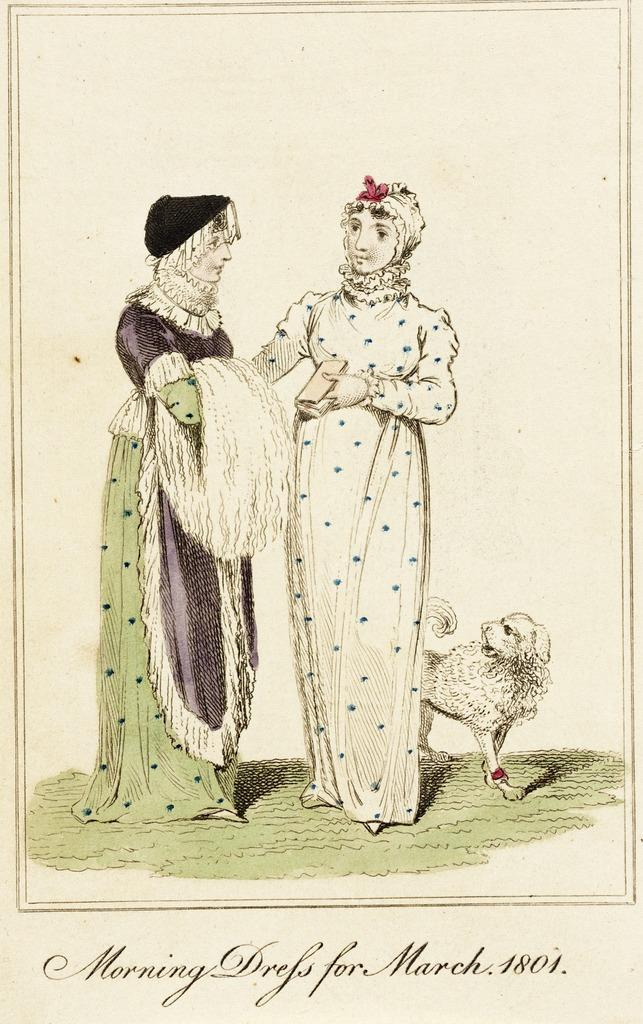What is depicted in the foreground of the poster? There is a sketch of two women and a sketch of a dog in the foreground of the poster. What else can be found on the poster besides the sketches? There is some text at the bottom of the poster. What type of metal cord is used to connect the two women in the sketch? There is no metal cord connecting the two women in the sketch, as it is a drawing and not a photograph or a real-life scene. 